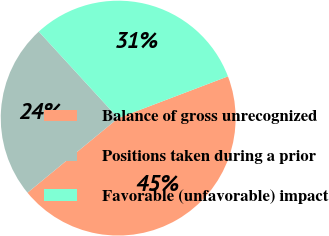Convert chart. <chart><loc_0><loc_0><loc_500><loc_500><pie_chart><fcel>Balance of gross unrecognized<fcel>Positions taken during a prior<fcel>Favorable (unfavorable) impact<nl><fcel>44.83%<fcel>24.14%<fcel>31.03%<nl></chart> 